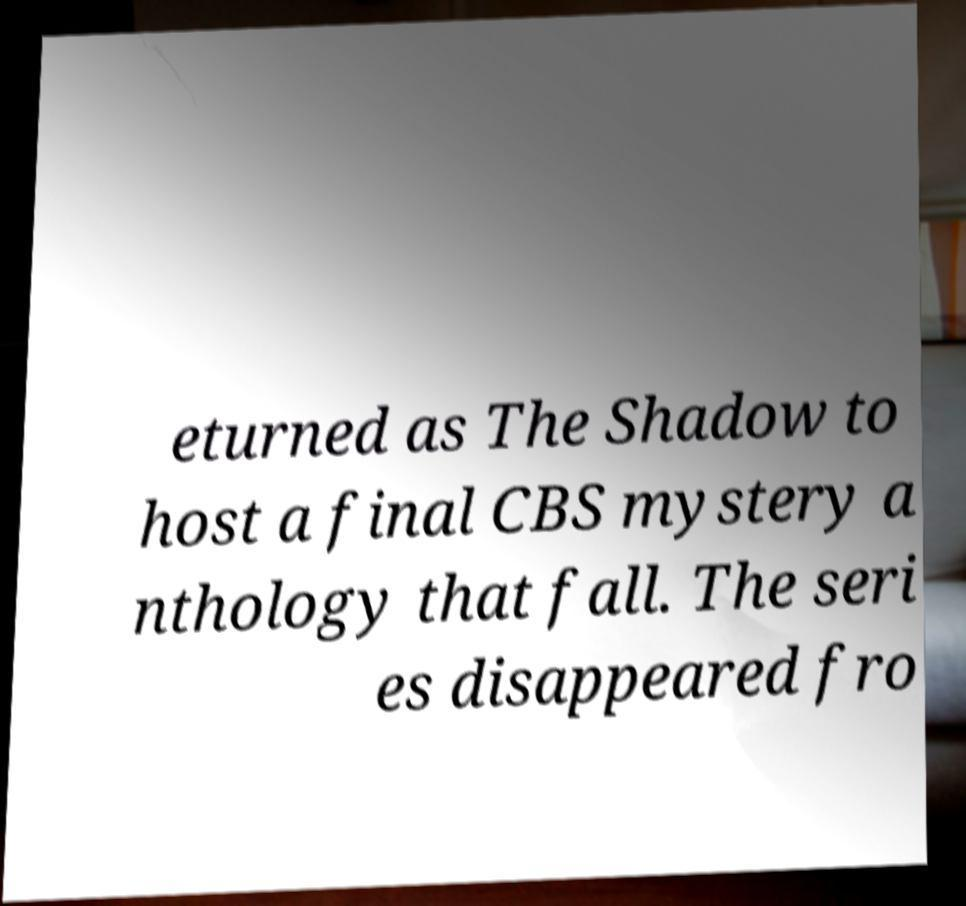Please identify and transcribe the text found in this image. eturned as The Shadow to host a final CBS mystery a nthology that fall. The seri es disappeared fro 